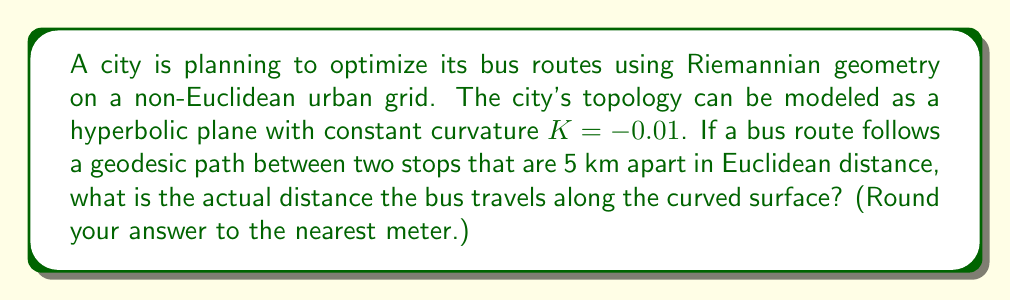Provide a solution to this math problem. To solve this problem, we'll use concepts from Riemannian geometry and hyperbolic space:

1) In a hyperbolic plane with constant negative curvature $K$, the distance $d$ along a geodesic between two points is related to the Euclidean distance $s$ by the formula:

   $$d = \frac{1}{\sqrt{-K}} \text{arcosh}(\text{cosh}(\sqrt{-K}s))$$

2) We're given:
   - Curvature $K = -0.01$
   - Euclidean distance $s = 5$ km $= 5000$ m

3) Let's substitute these values into the formula:

   $$d = \frac{1}{\sqrt{0.01}} \text{arcosh}(\text{cosh}(\sqrt{0.01} \cdot 5000))$$

4) Simplify:
   $$d = 10 \cdot \text{arcosh}(\text{cosh}(5\sqrt{10}))$$

5) Calculate $5\sqrt{10} \approx 15.8114$

6) Compute $\text{cosh}(15.8114) \approx 3,641,421.36$

7) Now, $d = 10 \cdot \text{arcosh}(3,641,421.36)$

8) Calculate: $d \approx 10 \cdot 15.8126 = 158.126$ m

9) Rounding to the nearest meter: $d \approx 5158$ m

Therefore, the actual distance the bus travels along the curved surface is approximately 5158 meters.
Answer: 5158 m 